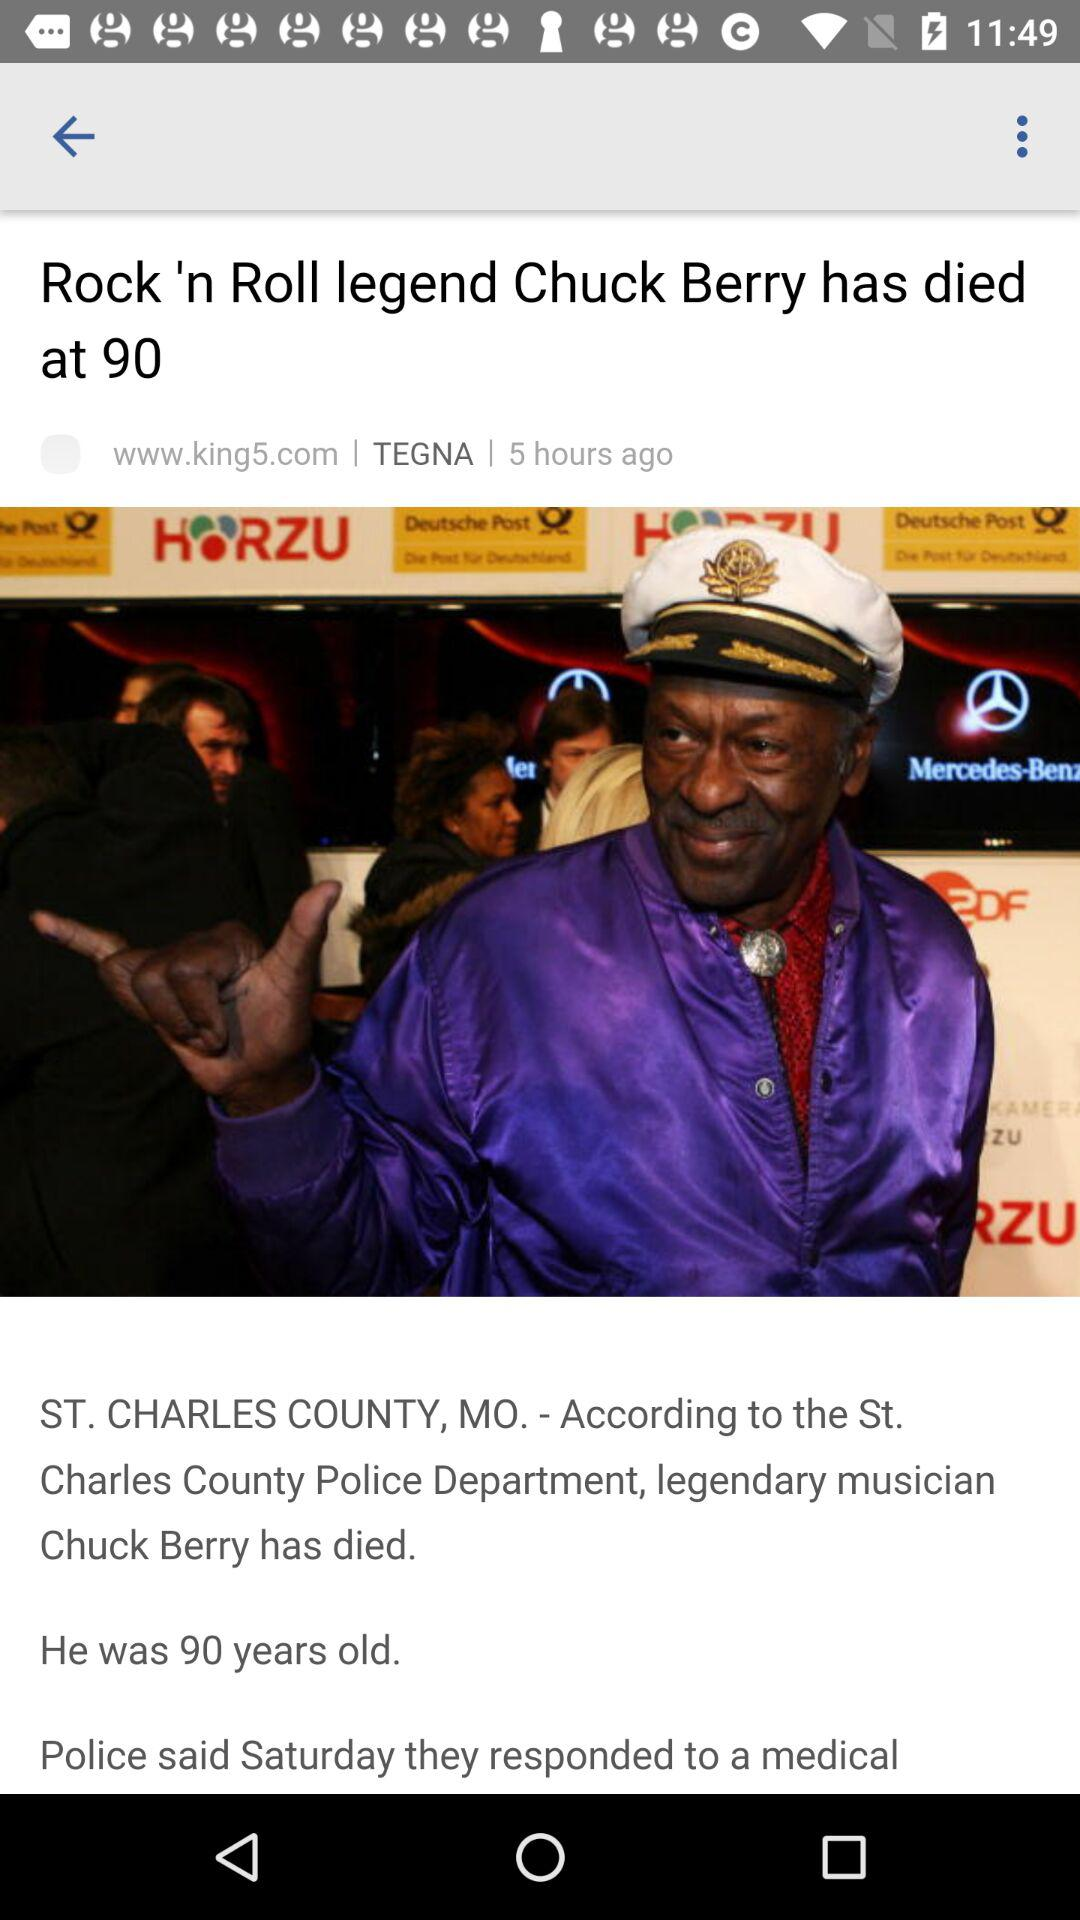Who is the rock 'n roll legend? The rock 'n roll legend is Chuck Berry. 